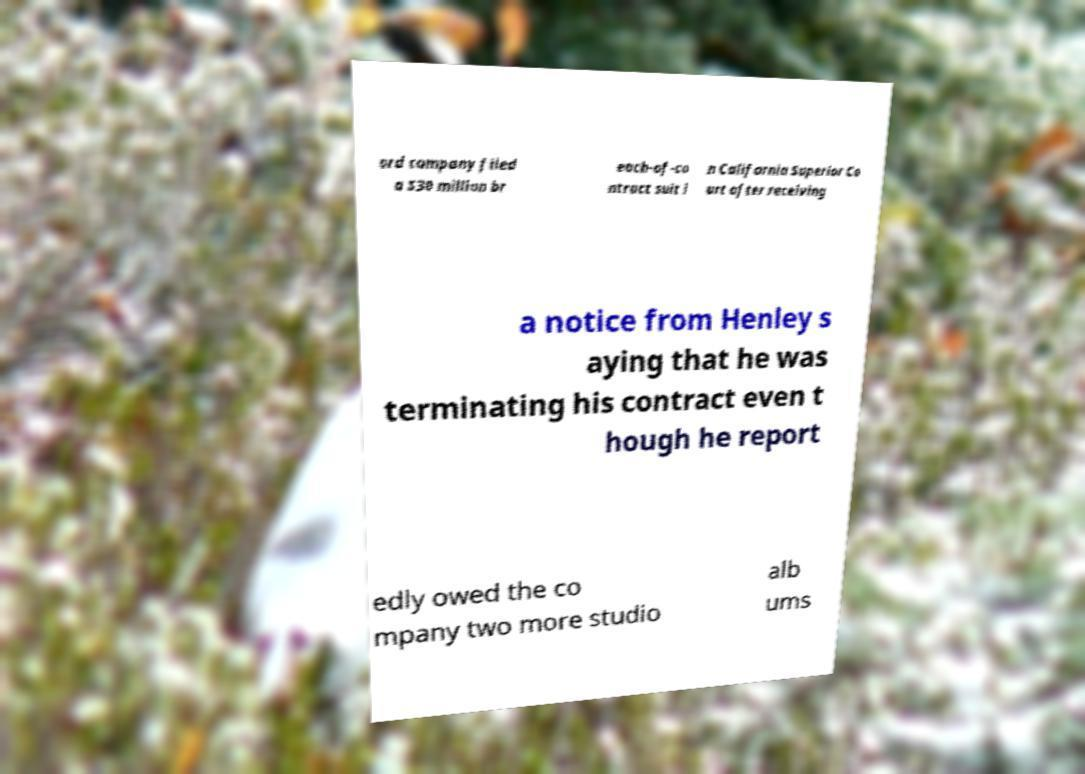I need the written content from this picture converted into text. Can you do that? ord company filed a $30 million br each-of-co ntract suit i n California Superior Co urt after receiving a notice from Henley s aying that he was terminating his contract even t hough he report edly owed the co mpany two more studio alb ums 